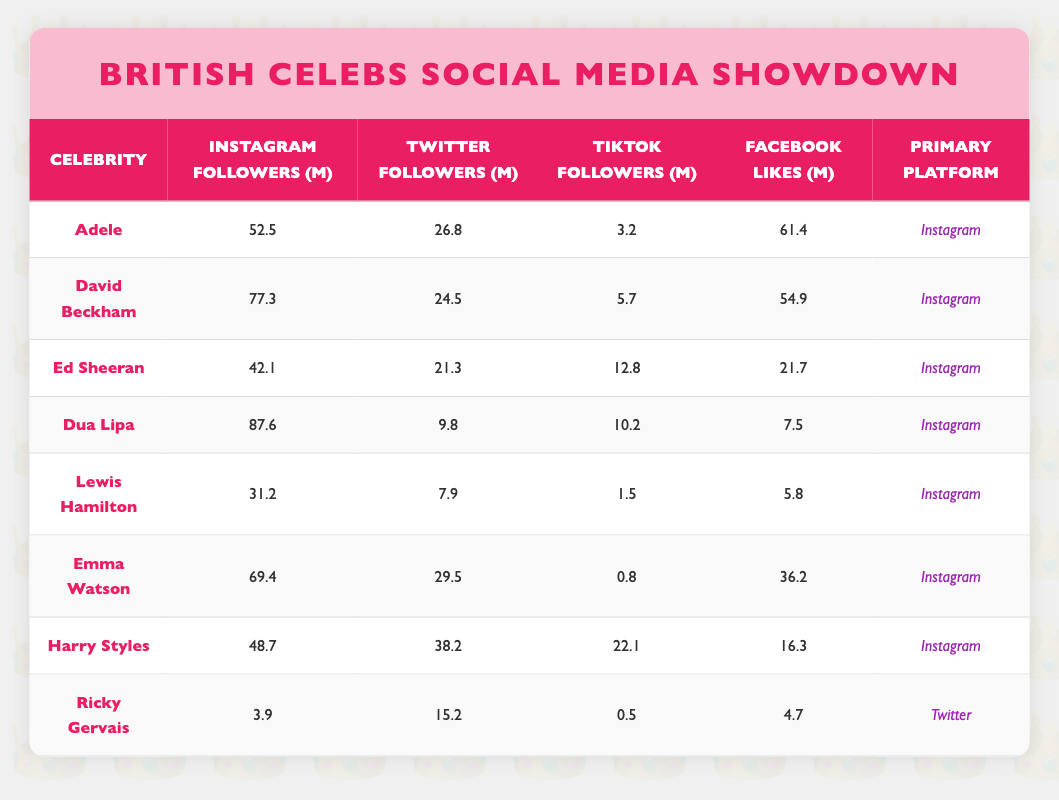What is the primary platform for David Beckham? In the table, under the "Primary Platform" column for David Beckham, it states "Instagram."
Answer: Instagram Who has the highest TikTok followers among the celebrities listed? By scanning the TikTok followers column, Dua Lipa has the highest count at 10.2 million.
Answer: Dua Lipa What is the combined total of Instagram followers for Emma Watson and Harry Styles? Emma Watson has 69.4 million and Harry Styles has 48.7 million. The sum is 69.4 + 48.7 = 118.1 million.
Answer: 118.1 million Is it true that Adele has more Facebook likes than Lewis Hamilton? Adele has 61.4 million Facebook likes while Lewis Hamilton has 5.8 million, making the statement true.
Answer: Yes Calculate the average number of Twitter followers among the celebrities listed in the table. Adding all Twitter followers: 26.8 + 24.5 + 21.3 + 9.8 + 7.9 + 29.5 + 38.2 + 15.2 = 172.2 million. Dividing by 8 gives an average of 21.525 million.
Answer: 21.525 million Which celebrity has the least number of Instagram followers? Looking at the Instagram followers column, Ricky Gervais has the least with 3.9 million followers.
Answer: Ricky Gervais Did any of the celebrities have more Facebook likes than their Instagram followers? Comparing values from the table: Adele (61.4m) > 52.5m, David Beckham (54.9m) > 77.3m, and so on. Only Ricky Gervais did not satisfy this criterion. Thus, it is false for him only.
Answer: No What is the difference in Instagram followers between Dua Lipa and Ed Sheeran? Dua Lipa has 87.6 million followers, while Ed Sheeran has 42.1 million; thus, the difference is 87.6 - 42.1 = 45.5 million.
Answer: 45.5 million How many celebrities have their primary platform as Instagram? From the table, seven out of the eight celebrities listed have "Instagram" as their primary platform.
Answer: 7 